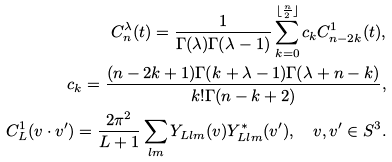Convert formula to latex. <formula><loc_0><loc_0><loc_500><loc_500>C _ { n } ^ { \lambda } ( t ) = \frac { 1 } { \Gamma ( \lambda ) \Gamma ( \lambda - 1 ) } \sum _ { k = 0 } ^ { \lfloor \frac { n } { 2 } \rfloor } c _ { k } C _ { n - 2 k } ^ { 1 } ( t ) , \\ c _ { k } = \frac { ( n - 2 k + 1 ) \Gamma ( k + \lambda - 1 ) \Gamma ( \lambda + n - k ) } { k ! \Gamma ( n - k + 2 ) } , \\ C _ { L } ^ { 1 } ( v \cdot v ^ { \prime } ) = \frac { 2 \pi ^ { 2 } } { L + 1 } \sum _ { l m } Y _ { L l m } ( v ) Y ^ { \ast } _ { L l m } ( v ^ { \prime } ) , \quad v , v ^ { \prime } \in S ^ { 3 } .</formula> 